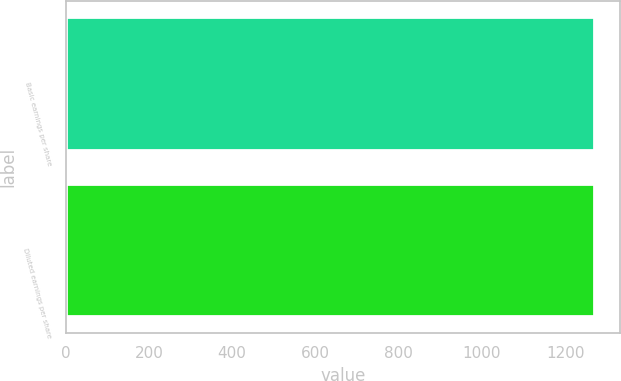Convert chart to OTSL. <chart><loc_0><loc_0><loc_500><loc_500><bar_chart><fcel>Basic earnings per share<fcel>Diluted earnings per share<nl><fcel>1268.2<fcel>1268.3<nl></chart> 